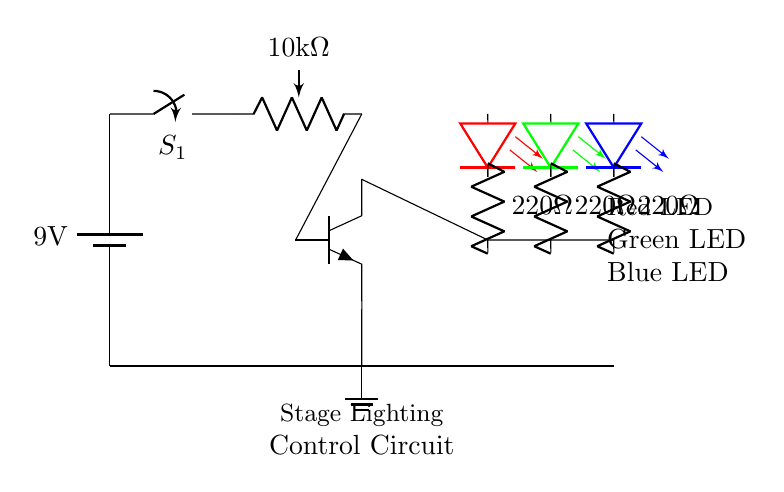What is the voltage of the battery used in the circuit? The circuit uses a 9V battery as shown at the power source in the circuit diagram.
Answer: 9 volts What is the purpose of the potentiometer in this circuit? The potentiometer is for brightness control, allowing the user to adjust the intensity of the LEDs.
Answer: Brightness control How many LEDs are present in this circuit? There are three LEDs: red, green, and blue connected in parallel within the circuit diagram.
Answer: Three What is the resistance value of each LED's resistor? Each LED is connected to a resistor labeled as 220 ohms, which limits the current flowing through the LEDs.
Answer: 220 ohms What is the role of the transistor in this circuit? The transistor acts as a switch to control the current flowing through the LED array based on the signal it receives from the potentiometer.
Answer: Switch Which component is used to turn the circuit on or off? The switch labeled S1 is used to control the power flow, turning the circuit on or off.
Answer: S1 What component connects the transistor to the LEDs? The collector terminal of the transistor connects to the common point of the resistors for the LEDs facilitating the control of current.
Answer: Collector terminal 